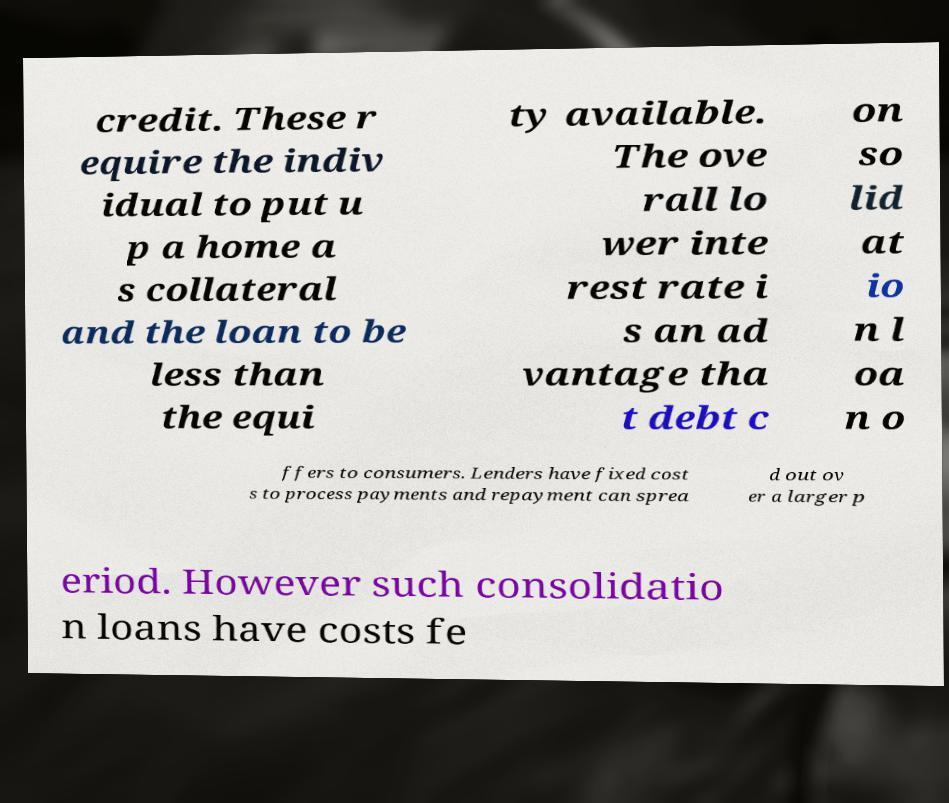There's text embedded in this image that I need extracted. Can you transcribe it verbatim? credit. These r equire the indiv idual to put u p a home a s collateral and the loan to be less than the equi ty available. The ove rall lo wer inte rest rate i s an ad vantage tha t debt c on so lid at io n l oa n o ffers to consumers. Lenders have fixed cost s to process payments and repayment can sprea d out ov er a larger p eriod. However such consolidatio n loans have costs fe 